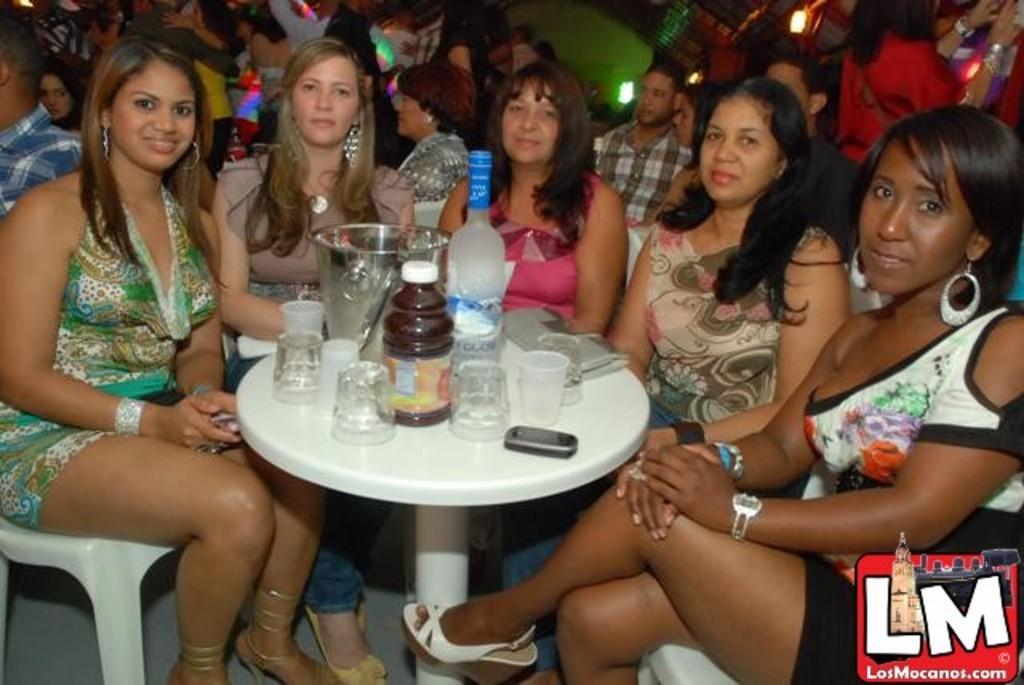Could you give a brief overview of what you see in this image? In this image I can see number of people were few women are sitting on chairs. On this table I can see few glasses and a bottle. 